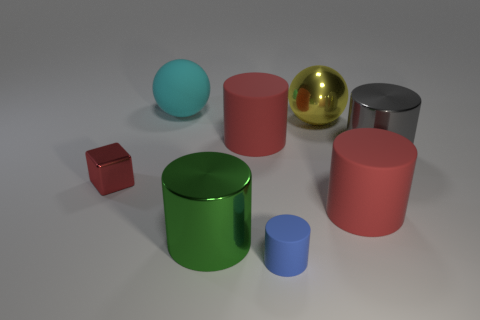Subtract all cyan balls. How many red cylinders are left? 2 Subtract all big red rubber cylinders. How many cylinders are left? 3 Subtract all green cylinders. How many cylinders are left? 4 Add 1 small red objects. How many objects exist? 9 Subtract all green cylinders. Subtract all green balls. How many cylinders are left? 4 Subtract all cylinders. How many objects are left? 3 Subtract all large gray cylinders. Subtract all cylinders. How many objects are left? 2 Add 7 small red shiny cubes. How many small red shiny cubes are left? 8 Add 2 gray things. How many gray things exist? 3 Subtract 0 blue cubes. How many objects are left? 8 